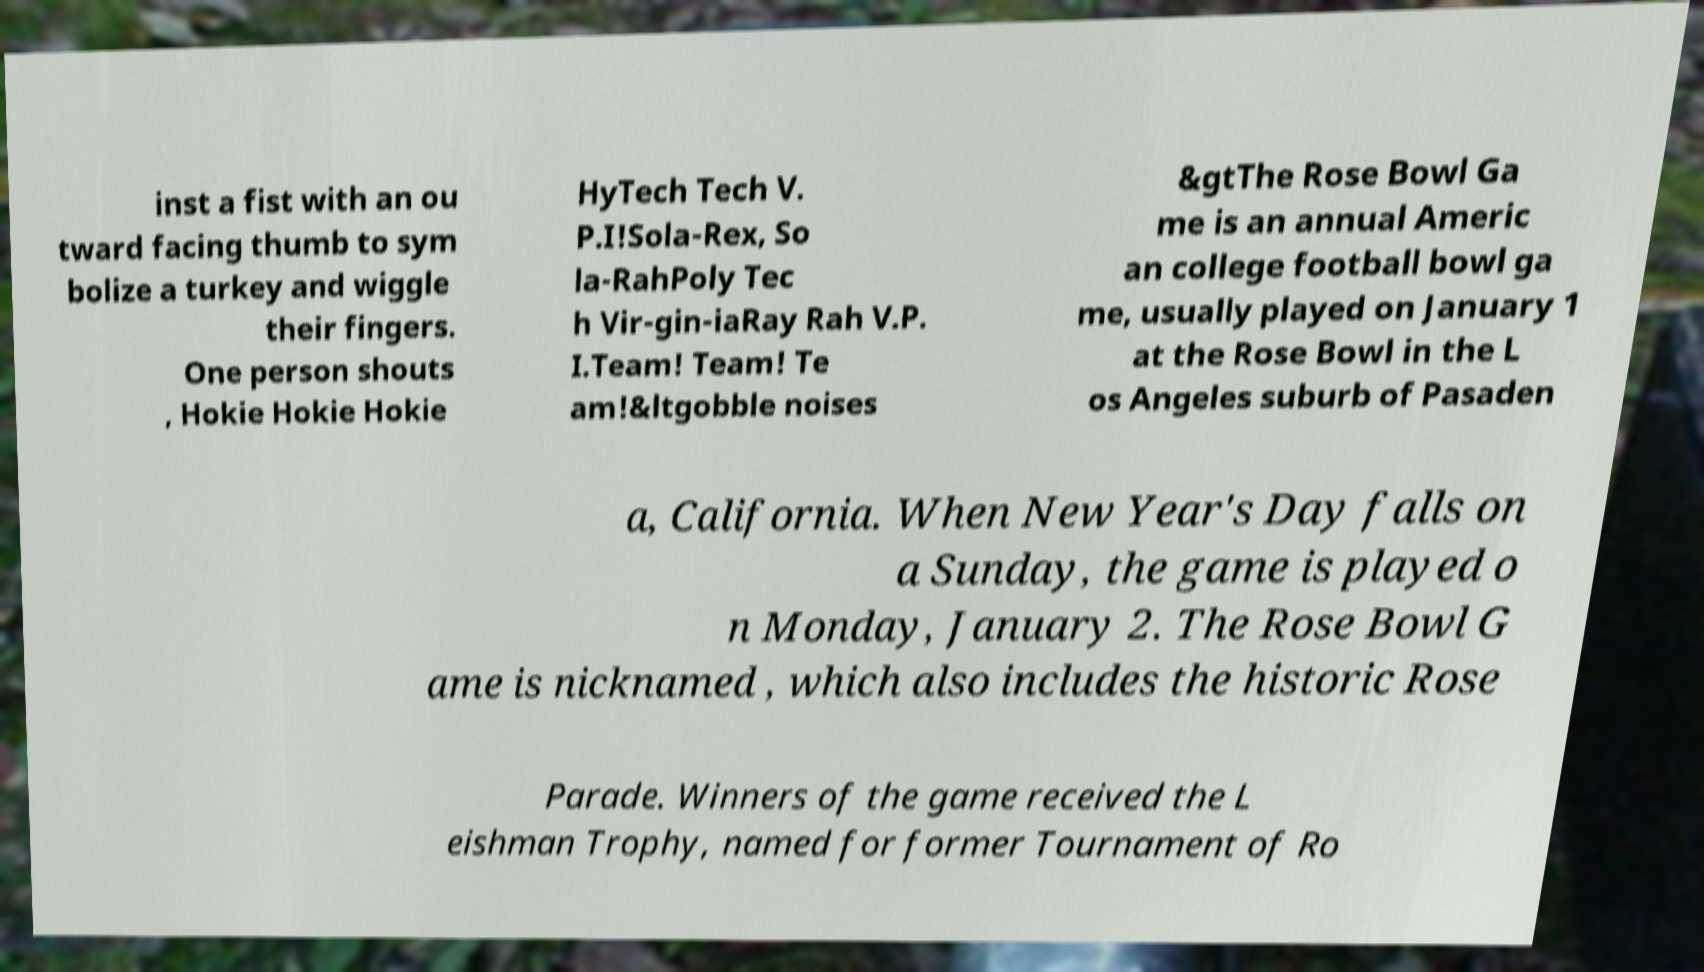Please read and relay the text visible in this image. What does it say? inst a fist with an ou tward facing thumb to sym bolize a turkey and wiggle their fingers. One person shouts , Hokie Hokie Hokie HyTech Tech V. P.I!Sola-Rex, So la-RahPoly Tec h Vir-gin-iaRay Rah V.P. I.Team! Team! Te am!&ltgobble noises &gtThe Rose Bowl Ga me is an annual Americ an college football bowl ga me, usually played on January 1 at the Rose Bowl in the L os Angeles suburb of Pasaden a, California. When New Year's Day falls on a Sunday, the game is played o n Monday, January 2. The Rose Bowl G ame is nicknamed , which also includes the historic Rose Parade. Winners of the game received the L eishman Trophy, named for former Tournament of Ro 